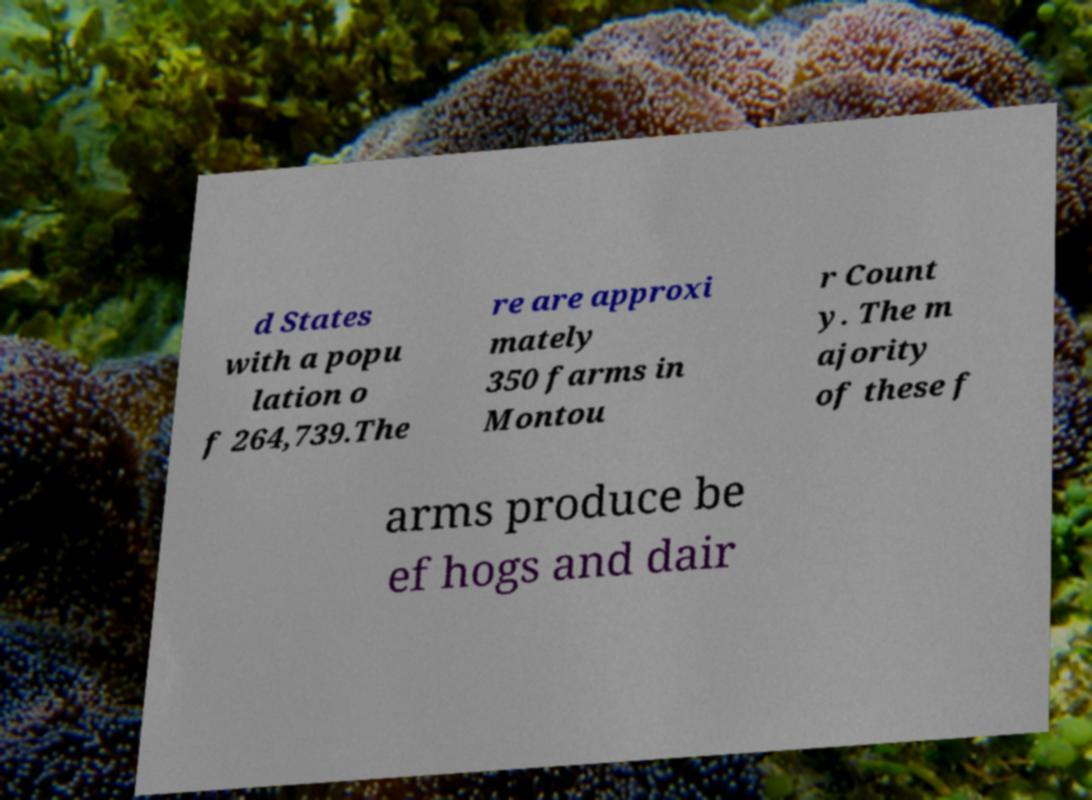What messages or text are displayed in this image? I need them in a readable, typed format. d States with a popu lation o f 264,739.The re are approxi mately 350 farms in Montou r Count y. The m ajority of these f arms produce be ef hogs and dair 